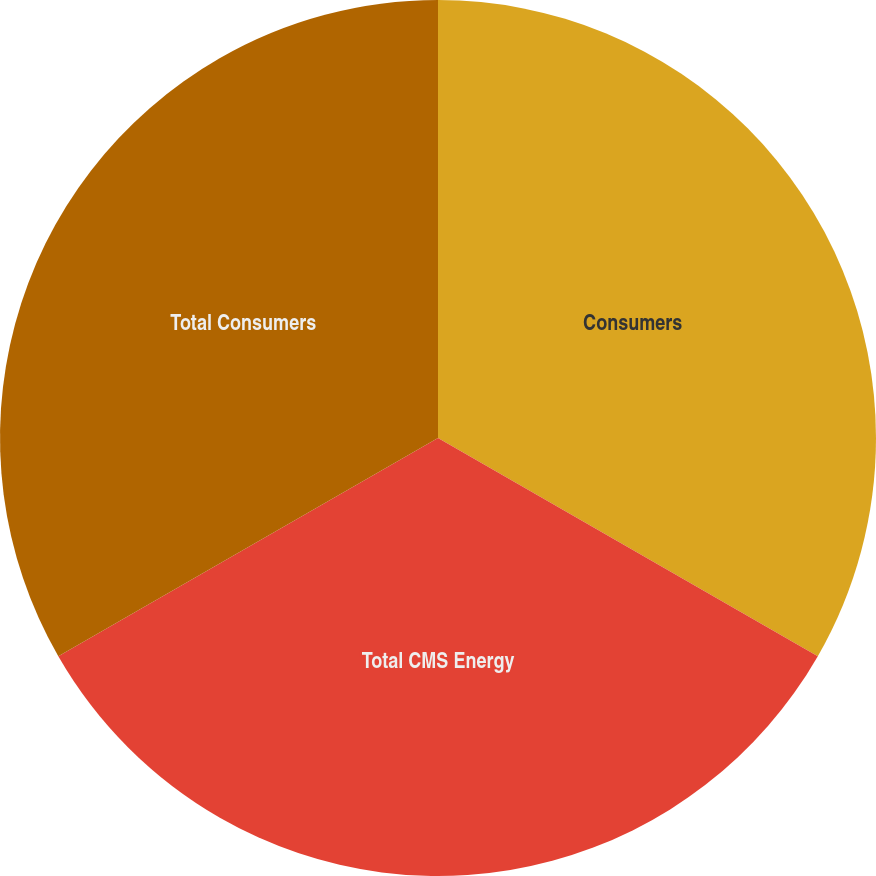Convert chart to OTSL. <chart><loc_0><loc_0><loc_500><loc_500><pie_chart><fcel>Consumers<fcel>Total CMS Energy<fcel>Total Consumers<nl><fcel>33.3%<fcel>33.4%<fcel>33.31%<nl></chart> 